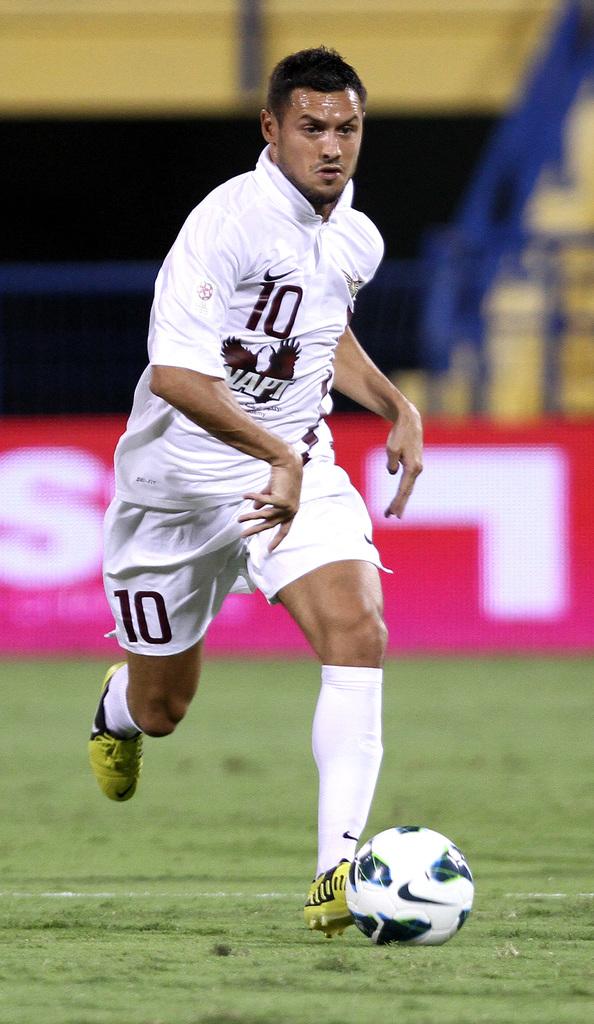What number is this player?
Offer a terse response. 10. 